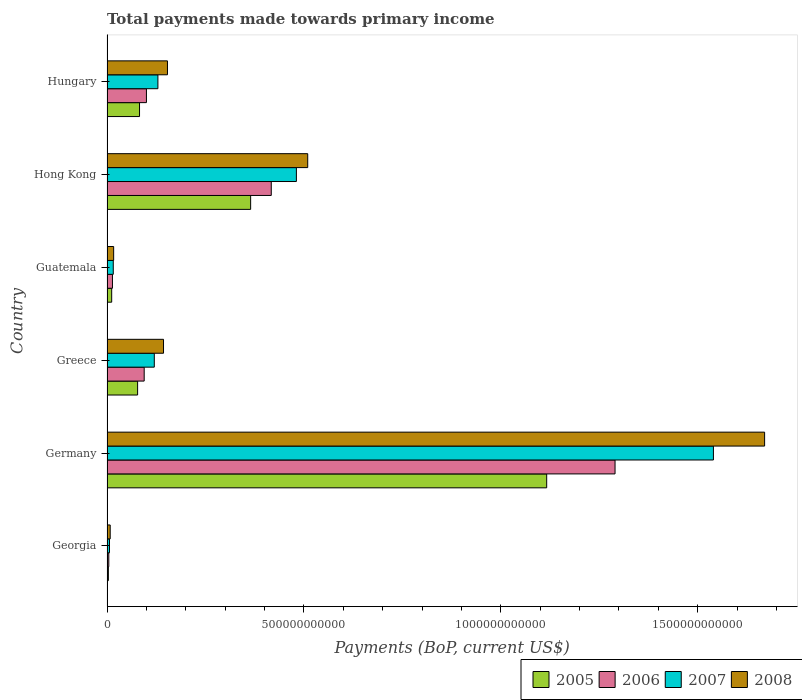How many different coloured bars are there?
Offer a terse response. 4. How many groups of bars are there?
Give a very brief answer. 6. Are the number of bars on each tick of the Y-axis equal?
Give a very brief answer. Yes. What is the label of the 3rd group of bars from the top?
Your answer should be compact. Guatemala. In how many cases, is the number of bars for a given country not equal to the number of legend labels?
Provide a short and direct response. 0. What is the total payments made towards primary income in 2008 in Hong Kong?
Ensure brevity in your answer.  5.10e+11. Across all countries, what is the maximum total payments made towards primary income in 2006?
Give a very brief answer. 1.29e+12. Across all countries, what is the minimum total payments made towards primary income in 2006?
Make the answer very short. 4.56e+09. In which country was the total payments made towards primary income in 2007 maximum?
Ensure brevity in your answer.  Germany. In which country was the total payments made towards primary income in 2007 minimum?
Your answer should be very brief. Georgia. What is the total total payments made towards primary income in 2006 in the graph?
Make the answer very short. 1.92e+12. What is the difference between the total payments made towards primary income in 2007 in Germany and that in Guatemala?
Keep it short and to the point. 1.52e+12. What is the difference between the total payments made towards primary income in 2007 in Guatemala and the total payments made towards primary income in 2005 in Germany?
Offer a very short reply. -1.10e+12. What is the average total payments made towards primary income in 2005 per country?
Ensure brevity in your answer.  2.76e+11. What is the difference between the total payments made towards primary income in 2006 and total payments made towards primary income in 2008 in Hong Kong?
Provide a succinct answer. -9.26e+1. In how many countries, is the total payments made towards primary income in 2007 greater than 1600000000000 US$?
Give a very brief answer. 0. What is the ratio of the total payments made towards primary income in 2005 in Germany to that in Hong Kong?
Ensure brevity in your answer.  3.06. Is the total payments made towards primary income in 2006 in Guatemala less than that in Hong Kong?
Provide a succinct answer. Yes. Is the difference between the total payments made towards primary income in 2006 in Germany and Hong Kong greater than the difference between the total payments made towards primary income in 2008 in Germany and Hong Kong?
Give a very brief answer. No. What is the difference between the highest and the second highest total payments made towards primary income in 2007?
Provide a short and direct response. 1.06e+12. What is the difference between the highest and the lowest total payments made towards primary income in 2008?
Provide a short and direct response. 1.66e+12. What does the 1st bar from the bottom in Hong Kong represents?
Keep it short and to the point. 2005. Are all the bars in the graph horizontal?
Ensure brevity in your answer.  Yes. How many countries are there in the graph?
Ensure brevity in your answer.  6. What is the difference between two consecutive major ticks on the X-axis?
Offer a very short reply. 5.00e+11. Does the graph contain grids?
Provide a short and direct response. No. Where does the legend appear in the graph?
Provide a succinct answer. Bottom right. What is the title of the graph?
Offer a terse response. Total payments made towards primary income. Does "2005" appear as one of the legend labels in the graph?
Give a very brief answer. Yes. What is the label or title of the X-axis?
Offer a terse response. Payments (BoP, current US$). What is the label or title of the Y-axis?
Ensure brevity in your answer.  Country. What is the Payments (BoP, current US$) of 2005 in Georgia?
Your answer should be very brief. 3.47e+09. What is the Payments (BoP, current US$) of 2006 in Georgia?
Provide a short and direct response. 4.56e+09. What is the Payments (BoP, current US$) of 2007 in Georgia?
Give a very brief answer. 6.32e+09. What is the Payments (BoP, current US$) in 2008 in Georgia?
Make the answer very short. 8.11e+09. What is the Payments (BoP, current US$) of 2005 in Germany?
Give a very brief answer. 1.12e+12. What is the Payments (BoP, current US$) of 2006 in Germany?
Offer a very short reply. 1.29e+12. What is the Payments (BoP, current US$) in 2007 in Germany?
Your answer should be very brief. 1.54e+12. What is the Payments (BoP, current US$) of 2008 in Germany?
Your answer should be compact. 1.67e+12. What is the Payments (BoP, current US$) in 2005 in Greece?
Offer a very short reply. 7.77e+1. What is the Payments (BoP, current US$) of 2006 in Greece?
Make the answer very short. 9.44e+1. What is the Payments (BoP, current US$) in 2007 in Greece?
Your response must be concise. 1.20e+11. What is the Payments (BoP, current US$) of 2008 in Greece?
Give a very brief answer. 1.44e+11. What is the Payments (BoP, current US$) of 2005 in Guatemala?
Ensure brevity in your answer.  1.19e+1. What is the Payments (BoP, current US$) of 2006 in Guatemala?
Give a very brief answer. 1.38e+1. What is the Payments (BoP, current US$) of 2007 in Guatemala?
Offer a very short reply. 1.59e+1. What is the Payments (BoP, current US$) in 2008 in Guatemala?
Offer a very short reply. 1.69e+1. What is the Payments (BoP, current US$) in 2005 in Hong Kong?
Your answer should be very brief. 3.65e+11. What is the Payments (BoP, current US$) of 2006 in Hong Kong?
Offer a terse response. 4.17e+11. What is the Payments (BoP, current US$) in 2007 in Hong Kong?
Your answer should be compact. 4.81e+11. What is the Payments (BoP, current US$) in 2008 in Hong Kong?
Ensure brevity in your answer.  5.10e+11. What is the Payments (BoP, current US$) of 2005 in Hungary?
Your answer should be compact. 8.26e+1. What is the Payments (BoP, current US$) of 2006 in Hungary?
Provide a short and direct response. 1.00e+11. What is the Payments (BoP, current US$) in 2007 in Hungary?
Keep it short and to the point. 1.29e+11. What is the Payments (BoP, current US$) of 2008 in Hungary?
Keep it short and to the point. 1.54e+11. Across all countries, what is the maximum Payments (BoP, current US$) of 2005?
Your answer should be very brief. 1.12e+12. Across all countries, what is the maximum Payments (BoP, current US$) in 2006?
Your answer should be compact. 1.29e+12. Across all countries, what is the maximum Payments (BoP, current US$) in 2007?
Offer a very short reply. 1.54e+12. Across all countries, what is the maximum Payments (BoP, current US$) of 2008?
Your response must be concise. 1.67e+12. Across all countries, what is the minimum Payments (BoP, current US$) in 2005?
Your answer should be compact. 3.47e+09. Across all countries, what is the minimum Payments (BoP, current US$) in 2006?
Provide a succinct answer. 4.56e+09. Across all countries, what is the minimum Payments (BoP, current US$) of 2007?
Provide a short and direct response. 6.32e+09. Across all countries, what is the minimum Payments (BoP, current US$) of 2008?
Provide a short and direct response. 8.11e+09. What is the total Payments (BoP, current US$) of 2005 in the graph?
Ensure brevity in your answer.  1.66e+12. What is the total Payments (BoP, current US$) in 2006 in the graph?
Give a very brief answer. 1.92e+12. What is the total Payments (BoP, current US$) of 2007 in the graph?
Offer a very short reply. 2.29e+12. What is the total Payments (BoP, current US$) in 2008 in the graph?
Ensure brevity in your answer.  2.50e+12. What is the difference between the Payments (BoP, current US$) of 2005 in Georgia and that in Germany?
Provide a succinct answer. -1.11e+12. What is the difference between the Payments (BoP, current US$) of 2006 in Georgia and that in Germany?
Offer a very short reply. -1.29e+12. What is the difference between the Payments (BoP, current US$) of 2007 in Georgia and that in Germany?
Ensure brevity in your answer.  -1.53e+12. What is the difference between the Payments (BoP, current US$) of 2008 in Georgia and that in Germany?
Ensure brevity in your answer.  -1.66e+12. What is the difference between the Payments (BoP, current US$) in 2005 in Georgia and that in Greece?
Offer a very short reply. -7.43e+1. What is the difference between the Payments (BoP, current US$) of 2006 in Georgia and that in Greece?
Offer a very short reply. -8.99e+1. What is the difference between the Payments (BoP, current US$) in 2007 in Georgia and that in Greece?
Your answer should be very brief. -1.14e+11. What is the difference between the Payments (BoP, current US$) of 2008 in Georgia and that in Greece?
Your response must be concise. -1.35e+11. What is the difference between the Payments (BoP, current US$) in 2005 in Georgia and that in Guatemala?
Provide a succinct answer. -8.42e+09. What is the difference between the Payments (BoP, current US$) of 2006 in Georgia and that in Guatemala?
Ensure brevity in your answer.  -9.27e+09. What is the difference between the Payments (BoP, current US$) of 2007 in Georgia and that in Guatemala?
Your answer should be compact. -9.59e+09. What is the difference between the Payments (BoP, current US$) of 2008 in Georgia and that in Guatemala?
Your answer should be compact. -8.77e+09. What is the difference between the Payments (BoP, current US$) of 2005 in Georgia and that in Hong Kong?
Keep it short and to the point. -3.61e+11. What is the difference between the Payments (BoP, current US$) in 2006 in Georgia and that in Hong Kong?
Keep it short and to the point. -4.13e+11. What is the difference between the Payments (BoP, current US$) of 2007 in Georgia and that in Hong Kong?
Provide a succinct answer. -4.75e+11. What is the difference between the Payments (BoP, current US$) in 2008 in Georgia and that in Hong Kong?
Keep it short and to the point. -5.02e+11. What is the difference between the Payments (BoP, current US$) in 2005 in Georgia and that in Hungary?
Your response must be concise. -7.91e+1. What is the difference between the Payments (BoP, current US$) of 2006 in Georgia and that in Hungary?
Your answer should be compact. -9.56e+1. What is the difference between the Payments (BoP, current US$) of 2007 in Georgia and that in Hungary?
Offer a terse response. -1.23e+11. What is the difference between the Payments (BoP, current US$) of 2008 in Georgia and that in Hungary?
Give a very brief answer. -1.45e+11. What is the difference between the Payments (BoP, current US$) of 2005 in Germany and that in Greece?
Keep it short and to the point. 1.04e+12. What is the difference between the Payments (BoP, current US$) of 2006 in Germany and that in Greece?
Provide a short and direct response. 1.20e+12. What is the difference between the Payments (BoP, current US$) of 2007 in Germany and that in Greece?
Keep it short and to the point. 1.42e+12. What is the difference between the Payments (BoP, current US$) of 2008 in Germany and that in Greece?
Ensure brevity in your answer.  1.53e+12. What is the difference between the Payments (BoP, current US$) of 2005 in Germany and that in Guatemala?
Provide a succinct answer. 1.10e+12. What is the difference between the Payments (BoP, current US$) in 2006 in Germany and that in Guatemala?
Offer a terse response. 1.28e+12. What is the difference between the Payments (BoP, current US$) in 2007 in Germany and that in Guatemala?
Your answer should be very brief. 1.52e+12. What is the difference between the Payments (BoP, current US$) of 2008 in Germany and that in Guatemala?
Your answer should be compact. 1.65e+12. What is the difference between the Payments (BoP, current US$) of 2005 in Germany and that in Hong Kong?
Keep it short and to the point. 7.52e+11. What is the difference between the Payments (BoP, current US$) of 2006 in Germany and that in Hong Kong?
Ensure brevity in your answer.  8.73e+11. What is the difference between the Payments (BoP, current US$) of 2007 in Germany and that in Hong Kong?
Your answer should be compact. 1.06e+12. What is the difference between the Payments (BoP, current US$) of 2008 in Germany and that in Hong Kong?
Give a very brief answer. 1.16e+12. What is the difference between the Payments (BoP, current US$) in 2005 in Germany and that in Hungary?
Provide a short and direct response. 1.03e+12. What is the difference between the Payments (BoP, current US$) of 2006 in Germany and that in Hungary?
Keep it short and to the point. 1.19e+12. What is the difference between the Payments (BoP, current US$) of 2007 in Germany and that in Hungary?
Keep it short and to the point. 1.41e+12. What is the difference between the Payments (BoP, current US$) in 2008 in Germany and that in Hungary?
Ensure brevity in your answer.  1.52e+12. What is the difference between the Payments (BoP, current US$) in 2005 in Greece and that in Guatemala?
Your answer should be very brief. 6.58e+1. What is the difference between the Payments (BoP, current US$) in 2006 in Greece and that in Guatemala?
Your response must be concise. 8.06e+1. What is the difference between the Payments (BoP, current US$) of 2007 in Greece and that in Guatemala?
Offer a very short reply. 1.04e+11. What is the difference between the Payments (BoP, current US$) of 2008 in Greece and that in Guatemala?
Your answer should be compact. 1.27e+11. What is the difference between the Payments (BoP, current US$) of 2005 in Greece and that in Hong Kong?
Make the answer very short. -2.87e+11. What is the difference between the Payments (BoP, current US$) in 2006 in Greece and that in Hong Kong?
Offer a terse response. -3.23e+11. What is the difference between the Payments (BoP, current US$) in 2007 in Greece and that in Hong Kong?
Make the answer very short. -3.61e+11. What is the difference between the Payments (BoP, current US$) of 2008 in Greece and that in Hong Kong?
Ensure brevity in your answer.  -3.66e+11. What is the difference between the Payments (BoP, current US$) in 2005 in Greece and that in Hungary?
Offer a terse response. -4.89e+09. What is the difference between the Payments (BoP, current US$) in 2006 in Greece and that in Hungary?
Keep it short and to the point. -5.71e+09. What is the difference between the Payments (BoP, current US$) of 2007 in Greece and that in Hungary?
Keep it short and to the point. -9.18e+09. What is the difference between the Payments (BoP, current US$) of 2008 in Greece and that in Hungary?
Offer a very short reply. -1.00e+1. What is the difference between the Payments (BoP, current US$) of 2005 in Guatemala and that in Hong Kong?
Your answer should be compact. -3.53e+11. What is the difference between the Payments (BoP, current US$) of 2006 in Guatemala and that in Hong Kong?
Provide a succinct answer. -4.03e+11. What is the difference between the Payments (BoP, current US$) of 2007 in Guatemala and that in Hong Kong?
Make the answer very short. -4.65e+11. What is the difference between the Payments (BoP, current US$) of 2008 in Guatemala and that in Hong Kong?
Your answer should be very brief. -4.93e+11. What is the difference between the Payments (BoP, current US$) in 2005 in Guatemala and that in Hungary?
Provide a succinct answer. -7.07e+1. What is the difference between the Payments (BoP, current US$) of 2006 in Guatemala and that in Hungary?
Your answer should be very brief. -8.63e+1. What is the difference between the Payments (BoP, current US$) of 2007 in Guatemala and that in Hungary?
Ensure brevity in your answer.  -1.13e+11. What is the difference between the Payments (BoP, current US$) of 2008 in Guatemala and that in Hungary?
Offer a terse response. -1.37e+11. What is the difference between the Payments (BoP, current US$) in 2005 in Hong Kong and that in Hungary?
Offer a terse response. 2.82e+11. What is the difference between the Payments (BoP, current US$) in 2006 in Hong Kong and that in Hungary?
Your response must be concise. 3.17e+11. What is the difference between the Payments (BoP, current US$) in 2007 in Hong Kong and that in Hungary?
Provide a succinct answer. 3.52e+11. What is the difference between the Payments (BoP, current US$) in 2008 in Hong Kong and that in Hungary?
Your answer should be very brief. 3.56e+11. What is the difference between the Payments (BoP, current US$) in 2005 in Georgia and the Payments (BoP, current US$) in 2006 in Germany?
Offer a very short reply. -1.29e+12. What is the difference between the Payments (BoP, current US$) in 2005 in Georgia and the Payments (BoP, current US$) in 2007 in Germany?
Offer a very short reply. -1.54e+12. What is the difference between the Payments (BoP, current US$) of 2005 in Georgia and the Payments (BoP, current US$) of 2008 in Germany?
Your answer should be very brief. -1.67e+12. What is the difference between the Payments (BoP, current US$) of 2006 in Georgia and the Payments (BoP, current US$) of 2007 in Germany?
Offer a very short reply. -1.54e+12. What is the difference between the Payments (BoP, current US$) in 2006 in Georgia and the Payments (BoP, current US$) in 2008 in Germany?
Offer a terse response. -1.67e+12. What is the difference between the Payments (BoP, current US$) of 2007 in Georgia and the Payments (BoP, current US$) of 2008 in Germany?
Provide a succinct answer. -1.66e+12. What is the difference between the Payments (BoP, current US$) of 2005 in Georgia and the Payments (BoP, current US$) of 2006 in Greece?
Keep it short and to the point. -9.10e+1. What is the difference between the Payments (BoP, current US$) in 2005 in Georgia and the Payments (BoP, current US$) in 2007 in Greece?
Provide a succinct answer. -1.17e+11. What is the difference between the Payments (BoP, current US$) of 2005 in Georgia and the Payments (BoP, current US$) of 2008 in Greece?
Offer a very short reply. -1.40e+11. What is the difference between the Payments (BoP, current US$) in 2006 in Georgia and the Payments (BoP, current US$) in 2007 in Greece?
Your answer should be very brief. -1.16e+11. What is the difference between the Payments (BoP, current US$) of 2006 in Georgia and the Payments (BoP, current US$) of 2008 in Greece?
Give a very brief answer. -1.39e+11. What is the difference between the Payments (BoP, current US$) of 2007 in Georgia and the Payments (BoP, current US$) of 2008 in Greece?
Provide a short and direct response. -1.37e+11. What is the difference between the Payments (BoP, current US$) in 2005 in Georgia and the Payments (BoP, current US$) in 2006 in Guatemala?
Ensure brevity in your answer.  -1.04e+1. What is the difference between the Payments (BoP, current US$) of 2005 in Georgia and the Payments (BoP, current US$) of 2007 in Guatemala?
Ensure brevity in your answer.  -1.24e+1. What is the difference between the Payments (BoP, current US$) in 2005 in Georgia and the Payments (BoP, current US$) in 2008 in Guatemala?
Your answer should be very brief. -1.34e+1. What is the difference between the Payments (BoP, current US$) in 2006 in Georgia and the Payments (BoP, current US$) in 2007 in Guatemala?
Give a very brief answer. -1.14e+1. What is the difference between the Payments (BoP, current US$) in 2006 in Georgia and the Payments (BoP, current US$) in 2008 in Guatemala?
Offer a terse response. -1.23e+1. What is the difference between the Payments (BoP, current US$) in 2007 in Georgia and the Payments (BoP, current US$) in 2008 in Guatemala?
Offer a very short reply. -1.06e+1. What is the difference between the Payments (BoP, current US$) in 2005 in Georgia and the Payments (BoP, current US$) in 2006 in Hong Kong?
Your answer should be very brief. -4.14e+11. What is the difference between the Payments (BoP, current US$) in 2005 in Georgia and the Payments (BoP, current US$) in 2007 in Hong Kong?
Offer a very short reply. -4.77e+11. What is the difference between the Payments (BoP, current US$) in 2005 in Georgia and the Payments (BoP, current US$) in 2008 in Hong Kong?
Provide a succinct answer. -5.06e+11. What is the difference between the Payments (BoP, current US$) of 2006 in Georgia and the Payments (BoP, current US$) of 2007 in Hong Kong?
Your answer should be very brief. -4.76e+11. What is the difference between the Payments (BoP, current US$) of 2006 in Georgia and the Payments (BoP, current US$) of 2008 in Hong Kong?
Your answer should be very brief. -5.05e+11. What is the difference between the Payments (BoP, current US$) in 2007 in Georgia and the Payments (BoP, current US$) in 2008 in Hong Kong?
Make the answer very short. -5.03e+11. What is the difference between the Payments (BoP, current US$) of 2005 in Georgia and the Payments (BoP, current US$) of 2006 in Hungary?
Keep it short and to the point. -9.67e+1. What is the difference between the Payments (BoP, current US$) in 2005 in Georgia and the Payments (BoP, current US$) in 2007 in Hungary?
Your answer should be compact. -1.26e+11. What is the difference between the Payments (BoP, current US$) in 2005 in Georgia and the Payments (BoP, current US$) in 2008 in Hungary?
Provide a short and direct response. -1.50e+11. What is the difference between the Payments (BoP, current US$) of 2006 in Georgia and the Payments (BoP, current US$) of 2007 in Hungary?
Your answer should be compact. -1.25e+11. What is the difference between the Payments (BoP, current US$) of 2006 in Georgia and the Payments (BoP, current US$) of 2008 in Hungary?
Your answer should be very brief. -1.49e+11. What is the difference between the Payments (BoP, current US$) in 2007 in Georgia and the Payments (BoP, current US$) in 2008 in Hungary?
Ensure brevity in your answer.  -1.47e+11. What is the difference between the Payments (BoP, current US$) in 2005 in Germany and the Payments (BoP, current US$) in 2006 in Greece?
Keep it short and to the point. 1.02e+12. What is the difference between the Payments (BoP, current US$) in 2005 in Germany and the Payments (BoP, current US$) in 2007 in Greece?
Your answer should be compact. 9.96e+11. What is the difference between the Payments (BoP, current US$) in 2005 in Germany and the Payments (BoP, current US$) in 2008 in Greece?
Provide a succinct answer. 9.73e+11. What is the difference between the Payments (BoP, current US$) in 2006 in Germany and the Payments (BoP, current US$) in 2007 in Greece?
Offer a terse response. 1.17e+12. What is the difference between the Payments (BoP, current US$) of 2006 in Germany and the Payments (BoP, current US$) of 2008 in Greece?
Offer a terse response. 1.15e+12. What is the difference between the Payments (BoP, current US$) of 2007 in Germany and the Payments (BoP, current US$) of 2008 in Greece?
Ensure brevity in your answer.  1.40e+12. What is the difference between the Payments (BoP, current US$) in 2005 in Germany and the Payments (BoP, current US$) in 2006 in Guatemala?
Make the answer very short. 1.10e+12. What is the difference between the Payments (BoP, current US$) in 2005 in Germany and the Payments (BoP, current US$) in 2007 in Guatemala?
Your answer should be compact. 1.10e+12. What is the difference between the Payments (BoP, current US$) in 2005 in Germany and the Payments (BoP, current US$) in 2008 in Guatemala?
Your answer should be compact. 1.10e+12. What is the difference between the Payments (BoP, current US$) in 2006 in Germany and the Payments (BoP, current US$) in 2007 in Guatemala?
Your answer should be very brief. 1.27e+12. What is the difference between the Payments (BoP, current US$) of 2006 in Germany and the Payments (BoP, current US$) of 2008 in Guatemala?
Keep it short and to the point. 1.27e+12. What is the difference between the Payments (BoP, current US$) in 2007 in Germany and the Payments (BoP, current US$) in 2008 in Guatemala?
Offer a very short reply. 1.52e+12. What is the difference between the Payments (BoP, current US$) of 2005 in Germany and the Payments (BoP, current US$) of 2006 in Hong Kong?
Keep it short and to the point. 6.99e+11. What is the difference between the Payments (BoP, current US$) in 2005 in Germany and the Payments (BoP, current US$) in 2007 in Hong Kong?
Your answer should be very brief. 6.36e+11. What is the difference between the Payments (BoP, current US$) in 2005 in Germany and the Payments (BoP, current US$) in 2008 in Hong Kong?
Give a very brief answer. 6.07e+11. What is the difference between the Payments (BoP, current US$) of 2006 in Germany and the Payments (BoP, current US$) of 2007 in Hong Kong?
Provide a succinct answer. 8.09e+11. What is the difference between the Payments (BoP, current US$) in 2006 in Germany and the Payments (BoP, current US$) in 2008 in Hong Kong?
Provide a short and direct response. 7.80e+11. What is the difference between the Payments (BoP, current US$) in 2007 in Germany and the Payments (BoP, current US$) in 2008 in Hong Kong?
Your answer should be compact. 1.03e+12. What is the difference between the Payments (BoP, current US$) in 2005 in Germany and the Payments (BoP, current US$) in 2006 in Hungary?
Your answer should be very brief. 1.02e+12. What is the difference between the Payments (BoP, current US$) in 2005 in Germany and the Payments (BoP, current US$) in 2007 in Hungary?
Keep it short and to the point. 9.87e+11. What is the difference between the Payments (BoP, current US$) in 2005 in Germany and the Payments (BoP, current US$) in 2008 in Hungary?
Give a very brief answer. 9.63e+11. What is the difference between the Payments (BoP, current US$) in 2006 in Germany and the Payments (BoP, current US$) in 2007 in Hungary?
Offer a terse response. 1.16e+12. What is the difference between the Payments (BoP, current US$) in 2006 in Germany and the Payments (BoP, current US$) in 2008 in Hungary?
Provide a short and direct response. 1.14e+12. What is the difference between the Payments (BoP, current US$) of 2007 in Germany and the Payments (BoP, current US$) of 2008 in Hungary?
Make the answer very short. 1.39e+12. What is the difference between the Payments (BoP, current US$) of 2005 in Greece and the Payments (BoP, current US$) of 2006 in Guatemala?
Make the answer very short. 6.39e+1. What is the difference between the Payments (BoP, current US$) in 2005 in Greece and the Payments (BoP, current US$) in 2007 in Guatemala?
Provide a short and direct response. 6.18e+1. What is the difference between the Payments (BoP, current US$) of 2005 in Greece and the Payments (BoP, current US$) of 2008 in Guatemala?
Offer a terse response. 6.08e+1. What is the difference between the Payments (BoP, current US$) of 2006 in Greece and the Payments (BoP, current US$) of 2007 in Guatemala?
Keep it short and to the point. 7.85e+1. What is the difference between the Payments (BoP, current US$) of 2006 in Greece and the Payments (BoP, current US$) of 2008 in Guatemala?
Give a very brief answer. 7.76e+1. What is the difference between the Payments (BoP, current US$) of 2007 in Greece and the Payments (BoP, current US$) of 2008 in Guatemala?
Make the answer very short. 1.03e+11. What is the difference between the Payments (BoP, current US$) of 2005 in Greece and the Payments (BoP, current US$) of 2006 in Hong Kong?
Your response must be concise. -3.39e+11. What is the difference between the Payments (BoP, current US$) of 2005 in Greece and the Payments (BoP, current US$) of 2007 in Hong Kong?
Make the answer very short. -4.03e+11. What is the difference between the Payments (BoP, current US$) in 2005 in Greece and the Payments (BoP, current US$) in 2008 in Hong Kong?
Make the answer very short. -4.32e+11. What is the difference between the Payments (BoP, current US$) of 2006 in Greece and the Payments (BoP, current US$) of 2007 in Hong Kong?
Provide a short and direct response. -3.86e+11. What is the difference between the Payments (BoP, current US$) in 2006 in Greece and the Payments (BoP, current US$) in 2008 in Hong Kong?
Your answer should be compact. -4.15e+11. What is the difference between the Payments (BoP, current US$) of 2007 in Greece and the Payments (BoP, current US$) of 2008 in Hong Kong?
Provide a short and direct response. -3.90e+11. What is the difference between the Payments (BoP, current US$) of 2005 in Greece and the Payments (BoP, current US$) of 2006 in Hungary?
Your response must be concise. -2.24e+1. What is the difference between the Payments (BoP, current US$) in 2005 in Greece and the Payments (BoP, current US$) in 2007 in Hungary?
Provide a short and direct response. -5.16e+1. What is the difference between the Payments (BoP, current US$) of 2005 in Greece and the Payments (BoP, current US$) of 2008 in Hungary?
Give a very brief answer. -7.58e+1. What is the difference between the Payments (BoP, current US$) in 2006 in Greece and the Payments (BoP, current US$) in 2007 in Hungary?
Keep it short and to the point. -3.48e+1. What is the difference between the Payments (BoP, current US$) in 2006 in Greece and the Payments (BoP, current US$) in 2008 in Hungary?
Give a very brief answer. -5.91e+1. What is the difference between the Payments (BoP, current US$) in 2007 in Greece and the Payments (BoP, current US$) in 2008 in Hungary?
Your answer should be very brief. -3.34e+1. What is the difference between the Payments (BoP, current US$) in 2005 in Guatemala and the Payments (BoP, current US$) in 2006 in Hong Kong?
Ensure brevity in your answer.  -4.05e+11. What is the difference between the Payments (BoP, current US$) of 2005 in Guatemala and the Payments (BoP, current US$) of 2007 in Hong Kong?
Offer a terse response. -4.69e+11. What is the difference between the Payments (BoP, current US$) of 2005 in Guatemala and the Payments (BoP, current US$) of 2008 in Hong Kong?
Your answer should be compact. -4.98e+11. What is the difference between the Payments (BoP, current US$) in 2006 in Guatemala and the Payments (BoP, current US$) in 2007 in Hong Kong?
Ensure brevity in your answer.  -4.67e+11. What is the difference between the Payments (BoP, current US$) in 2006 in Guatemala and the Payments (BoP, current US$) in 2008 in Hong Kong?
Give a very brief answer. -4.96e+11. What is the difference between the Payments (BoP, current US$) in 2007 in Guatemala and the Payments (BoP, current US$) in 2008 in Hong Kong?
Your answer should be very brief. -4.94e+11. What is the difference between the Payments (BoP, current US$) in 2005 in Guatemala and the Payments (BoP, current US$) in 2006 in Hungary?
Your response must be concise. -8.83e+1. What is the difference between the Payments (BoP, current US$) in 2005 in Guatemala and the Payments (BoP, current US$) in 2007 in Hungary?
Make the answer very short. -1.17e+11. What is the difference between the Payments (BoP, current US$) in 2005 in Guatemala and the Payments (BoP, current US$) in 2008 in Hungary?
Provide a short and direct response. -1.42e+11. What is the difference between the Payments (BoP, current US$) in 2006 in Guatemala and the Payments (BoP, current US$) in 2007 in Hungary?
Provide a succinct answer. -1.15e+11. What is the difference between the Payments (BoP, current US$) in 2006 in Guatemala and the Payments (BoP, current US$) in 2008 in Hungary?
Provide a succinct answer. -1.40e+11. What is the difference between the Payments (BoP, current US$) in 2007 in Guatemala and the Payments (BoP, current US$) in 2008 in Hungary?
Your answer should be very brief. -1.38e+11. What is the difference between the Payments (BoP, current US$) of 2005 in Hong Kong and the Payments (BoP, current US$) of 2006 in Hungary?
Keep it short and to the point. 2.65e+11. What is the difference between the Payments (BoP, current US$) in 2005 in Hong Kong and the Payments (BoP, current US$) in 2007 in Hungary?
Your answer should be very brief. 2.35e+11. What is the difference between the Payments (BoP, current US$) in 2005 in Hong Kong and the Payments (BoP, current US$) in 2008 in Hungary?
Your answer should be compact. 2.11e+11. What is the difference between the Payments (BoP, current US$) in 2006 in Hong Kong and the Payments (BoP, current US$) in 2007 in Hungary?
Your answer should be compact. 2.88e+11. What is the difference between the Payments (BoP, current US$) in 2006 in Hong Kong and the Payments (BoP, current US$) in 2008 in Hungary?
Your answer should be compact. 2.64e+11. What is the difference between the Payments (BoP, current US$) of 2007 in Hong Kong and the Payments (BoP, current US$) of 2008 in Hungary?
Offer a very short reply. 3.27e+11. What is the average Payments (BoP, current US$) of 2005 per country?
Keep it short and to the point. 2.76e+11. What is the average Payments (BoP, current US$) in 2006 per country?
Give a very brief answer. 3.20e+11. What is the average Payments (BoP, current US$) in 2007 per country?
Your answer should be compact. 3.82e+11. What is the average Payments (BoP, current US$) in 2008 per country?
Give a very brief answer. 4.17e+11. What is the difference between the Payments (BoP, current US$) of 2005 and Payments (BoP, current US$) of 2006 in Georgia?
Give a very brief answer. -1.09e+09. What is the difference between the Payments (BoP, current US$) in 2005 and Payments (BoP, current US$) in 2007 in Georgia?
Provide a succinct answer. -2.86e+09. What is the difference between the Payments (BoP, current US$) in 2005 and Payments (BoP, current US$) in 2008 in Georgia?
Offer a terse response. -4.65e+09. What is the difference between the Payments (BoP, current US$) in 2006 and Payments (BoP, current US$) in 2007 in Georgia?
Keep it short and to the point. -1.77e+09. What is the difference between the Payments (BoP, current US$) of 2006 and Payments (BoP, current US$) of 2008 in Georgia?
Keep it short and to the point. -3.56e+09. What is the difference between the Payments (BoP, current US$) in 2007 and Payments (BoP, current US$) in 2008 in Georgia?
Offer a terse response. -1.79e+09. What is the difference between the Payments (BoP, current US$) in 2005 and Payments (BoP, current US$) in 2006 in Germany?
Offer a very short reply. -1.74e+11. What is the difference between the Payments (BoP, current US$) in 2005 and Payments (BoP, current US$) in 2007 in Germany?
Offer a very short reply. -4.23e+11. What is the difference between the Payments (BoP, current US$) of 2005 and Payments (BoP, current US$) of 2008 in Germany?
Offer a very short reply. -5.53e+11. What is the difference between the Payments (BoP, current US$) of 2006 and Payments (BoP, current US$) of 2007 in Germany?
Your response must be concise. -2.50e+11. What is the difference between the Payments (BoP, current US$) of 2006 and Payments (BoP, current US$) of 2008 in Germany?
Your answer should be very brief. -3.80e+11. What is the difference between the Payments (BoP, current US$) of 2007 and Payments (BoP, current US$) of 2008 in Germany?
Keep it short and to the point. -1.30e+11. What is the difference between the Payments (BoP, current US$) in 2005 and Payments (BoP, current US$) in 2006 in Greece?
Offer a very short reply. -1.67e+1. What is the difference between the Payments (BoP, current US$) in 2005 and Payments (BoP, current US$) in 2007 in Greece?
Your answer should be compact. -4.24e+1. What is the difference between the Payments (BoP, current US$) of 2005 and Payments (BoP, current US$) of 2008 in Greece?
Your response must be concise. -6.58e+1. What is the difference between the Payments (BoP, current US$) in 2006 and Payments (BoP, current US$) in 2007 in Greece?
Make the answer very short. -2.56e+1. What is the difference between the Payments (BoP, current US$) in 2006 and Payments (BoP, current US$) in 2008 in Greece?
Your answer should be compact. -4.91e+1. What is the difference between the Payments (BoP, current US$) of 2007 and Payments (BoP, current US$) of 2008 in Greece?
Ensure brevity in your answer.  -2.34e+1. What is the difference between the Payments (BoP, current US$) of 2005 and Payments (BoP, current US$) of 2006 in Guatemala?
Provide a short and direct response. -1.94e+09. What is the difference between the Payments (BoP, current US$) in 2005 and Payments (BoP, current US$) in 2007 in Guatemala?
Make the answer very short. -4.02e+09. What is the difference between the Payments (BoP, current US$) of 2005 and Payments (BoP, current US$) of 2008 in Guatemala?
Give a very brief answer. -5.00e+09. What is the difference between the Payments (BoP, current US$) in 2006 and Payments (BoP, current US$) in 2007 in Guatemala?
Your answer should be very brief. -2.08e+09. What is the difference between the Payments (BoP, current US$) of 2006 and Payments (BoP, current US$) of 2008 in Guatemala?
Give a very brief answer. -3.06e+09. What is the difference between the Payments (BoP, current US$) in 2007 and Payments (BoP, current US$) in 2008 in Guatemala?
Your answer should be very brief. -9.78e+08. What is the difference between the Payments (BoP, current US$) of 2005 and Payments (BoP, current US$) of 2006 in Hong Kong?
Your response must be concise. -5.24e+1. What is the difference between the Payments (BoP, current US$) in 2005 and Payments (BoP, current US$) in 2007 in Hong Kong?
Provide a succinct answer. -1.16e+11. What is the difference between the Payments (BoP, current US$) of 2005 and Payments (BoP, current US$) of 2008 in Hong Kong?
Provide a short and direct response. -1.45e+11. What is the difference between the Payments (BoP, current US$) in 2006 and Payments (BoP, current US$) in 2007 in Hong Kong?
Keep it short and to the point. -6.38e+1. What is the difference between the Payments (BoP, current US$) in 2006 and Payments (BoP, current US$) in 2008 in Hong Kong?
Your answer should be very brief. -9.26e+1. What is the difference between the Payments (BoP, current US$) in 2007 and Payments (BoP, current US$) in 2008 in Hong Kong?
Make the answer very short. -2.88e+1. What is the difference between the Payments (BoP, current US$) of 2005 and Payments (BoP, current US$) of 2006 in Hungary?
Make the answer very short. -1.75e+1. What is the difference between the Payments (BoP, current US$) of 2005 and Payments (BoP, current US$) of 2007 in Hungary?
Offer a terse response. -4.67e+1. What is the difference between the Payments (BoP, current US$) of 2005 and Payments (BoP, current US$) of 2008 in Hungary?
Ensure brevity in your answer.  -7.09e+1. What is the difference between the Payments (BoP, current US$) of 2006 and Payments (BoP, current US$) of 2007 in Hungary?
Keep it short and to the point. -2.91e+1. What is the difference between the Payments (BoP, current US$) in 2006 and Payments (BoP, current US$) in 2008 in Hungary?
Your response must be concise. -5.34e+1. What is the difference between the Payments (BoP, current US$) in 2007 and Payments (BoP, current US$) in 2008 in Hungary?
Give a very brief answer. -2.43e+1. What is the ratio of the Payments (BoP, current US$) in 2005 in Georgia to that in Germany?
Offer a terse response. 0. What is the ratio of the Payments (BoP, current US$) of 2006 in Georgia to that in Germany?
Provide a short and direct response. 0. What is the ratio of the Payments (BoP, current US$) of 2007 in Georgia to that in Germany?
Offer a terse response. 0. What is the ratio of the Payments (BoP, current US$) of 2008 in Georgia to that in Germany?
Your answer should be compact. 0. What is the ratio of the Payments (BoP, current US$) of 2005 in Georgia to that in Greece?
Offer a terse response. 0.04. What is the ratio of the Payments (BoP, current US$) of 2006 in Georgia to that in Greece?
Your response must be concise. 0.05. What is the ratio of the Payments (BoP, current US$) in 2007 in Georgia to that in Greece?
Keep it short and to the point. 0.05. What is the ratio of the Payments (BoP, current US$) of 2008 in Georgia to that in Greece?
Your answer should be compact. 0.06. What is the ratio of the Payments (BoP, current US$) in 2005 in Georgia to that in Guatemala?
Offer a terse response. 0.29. What is the ratio of the Payments (BoP, current US$) in 2006 in Georgia to that in Guatemala?
Provide a succinct answer. 0.33. What is the ratio of the Payments (BoP, current US$) in 2007 in Georgia to that in Guatemala?
Make the answer very short. 0.4. What is the ratio of the Payments (BoP, current US$) of 2008 in Georgia to that in Guatemala?
Make the answer very short. 0.48. What is the ratio of the Payments (BoP, current US$) in 2005 in Georgia to that in Hong Kong?
Ensure brevity in your answer.  0.01. What is the ratio of the Payments (BoP, current US$) of 2006 in Georgia to that in Hong Kong?
Provide a succinct answer. 0.01. What is the ratio of the Payments (BoP, current US$) in 2007 in Georgia to that in Hong Kong?
Ensure brevity in your answer.  0.01. What is the ratio of the Payments (BoP, current US$) in 2008 in Georgia to that in Hong Kong?
Provide a succinct answer. 0.02. What is the ratio of the Payments (BoP, current US$) in 2005 in Georgia to that in Hungary?
Your answer should be compact. 0.04. What is the ratio of the Payments (BoP, current US$) of 2006 in Georgia to that in Hungary?
Your response must be concise. 0.05. What is the ratio of the Payments (BoP, current US$) of 2007 in Georgia to that in Hungary?
Provide a short and direct response. 0.05. What is the ratio of the Payments (BoP, current US$) in 2008 in Georgia to that in Hungary?
Ensure brevity in your answer.  0.05. What is the ratio of the Payments (BoP, current US$) in 2005 in Germany to that in Greece?
Your answer should be very brief. 14.37. What is the ratio of the Payments (BoP, current US$) of 2006 in Germany to that in Greece?
Your response must be concise. 13.66. What is the ratio of the Payments (BoP, current US$) of 2007 in Germany to that in Greece?
Keep it short and to the point. 12.82. What is the ratio of the Payments (BoP, current US$) of 2008 in Germany to that in Greece?
Provide a short and direct response. 11.64. What is the ratio of the Payments (BoP, current US$) in 2005 in Germany to that in Guatemala?
Provide a short and direct response. 93.94. What is the ratio of the Payments (BoP, current US$) of 2006 in Germany to that in Guatemala?
Provide a succinct answer. 93.3. What is the ratio of the Payments (BoP, current US$) of 2007 in Germany to that in Guatemala?
Ensure brevity in your answer.  96.79. What is the ratio of the Payments (BoP, current US$) of 2008 in Germany to that in Guatemala?
Offer a very short reply. 98.88. What is the ratio of the Payments (BoP, current US$) of 2005 in Germany to that in Hong Kong?
Keep it short and to the point. 3.06. What is the ratio of the Payments (BoP, current US$) in 2006 in Germany to that in Hong Kong?
Give a very brief answer. 3.09. What is the ratio of the Payments (BoP, current US$) in 2007 in Germany to that in Hong Kong?
Ensure brevity in your answer.  3.2. What is the ratio of the Payments (BoP, current US$) in 2008 in Germany to that in Hong Kong?
Give a very brief answer. 3.28. What is the ratio of the Payments (BoP, current US$) in 2005 in Germany to that in Hungary?
Offer a terse response. 13.52. What is the ratio of the Payments (BoP, current US$) of 2006 in Germany to that in Hungary?
Ensure brevity in your answer.  12.88. What is the ratio of the Payments (BoP, current US$) of 2007 in Germany to that in Hungary?
Offer a very short reply. 11.91. What is the ratio of the Payments (BoP, current US$) in 2008 in Germany to that in Hungary?
Offer a terse response. 10.88. What is the ratio of the Payments (BoP, current US$) in 2005 in Greece to that in Guatemala?
Make the answer very short. 6.54. What is the ratio of the Payments (BoP, current US$) in 2006 in Greece to that in Guatemala?
Ensure brevity in your answer.  6.83. What is the ratio of the Payments (BoP, current US$) in 2007 in Greece to that in Guatemala?
Your response must be concise. 7.55. What is the ratio of the Payments (BoP, current US$) in 2008 in Greece to that in Guatemala?
Offer a very short reply. 8.5. What is the ratio of the Payments (BoP, current US$) in 2005 in Greece to that in Hong Kong?
Your answer should be compact. 0.21. What is the ratio of the Payments (BoP, current US$) of 2006 in Greece to that in Hong Kong?
Keep it short and to the point. 0.23. What is the ratio of the Payments (BoP, current US$) in 2007 in Greece to that in Hong Kong?
Ensure brevity in your answer.  0.25. What is the ratio of the Payments (BoP, current US$) of 2008 in Greece to that in Hong Kong?
Provide a succinct answer. 0.28. What is the ratio of the Payments (BoP, current US$) of 2005 in Greece to that in Hungary?
Offer a terse response. 0.94. What is the ratio of the Payments (BoP, current US$) of 2006 in Greece to that in Hungary?
Your answer should be compact. 0.94. What is the ratio of the Payments (BoP, current US$) in 2007 in Greece to that in Hungary?
Offer a terse response. 0.93. What is the ratio of the Payments (BoP, current US$) in 2008 in Greece to that in Hungary?
Provide a succinct answer. 0.93. What is the ratio of the Payments (BoP, current US$) in 2005 in Guatemala to that in Hong Kong?
Offer a terse response. 0.03. What is the ratio of the Payments (BoP, current US$) of 2006 in Guatemala to that in Hong Kong?
Offer a very short reply. 0.03. What is the ratio of the Payments (BoP, current US$) in 2007 in Guatemala to that in Hong Kong?
Provide a short and direct response. 0.03. What is the ratio of the Payments (BoP, current US$) of 2008 in Guatemala to that in Hong Kong?
Offer a terse response. 0.03. What is the ratio of the Payments (BoP, current US$) in 2005 in Guatemala to that in Hungary?
Your response must be concise. 0.14. What is the ratio of the Payments (BoP, current US$) of 2006 in Guatemala to that in Hungary?
Give a very brief answer. 0.14. What is the ratio of the Payments (BoP, current US$) in 2007 in Guatemala to that in Hungary?
Keep it short and to the point. 0.12. What is the ratio of the Payments (BoP, current US$) in 2008 in Guatemala to that in Hungary?
Your answer should be compact. 0.11. What is the ratio of the Payments (BoP, current US$) of 2005 in Hong Kong to that in Hungary?
Your response must be concise. 4.42. What is the ratio of the Payments (BoP, current US$) in 2006 in Hong Kong to that in Hungary?
Your answer should be compact. 4.17. What is the ratio of the Payments (BoP, current US$) of 2007 in Hong Kong to that in Hungary?
Ensure brevity in your answer.  3.72. What is the ratio of the Payments (BoP, current US$) in 2008 in Hong Kong to that in Hungary?
Offer a very short reply. 3.32. What is the difference between the highest and the second highest Payments (BoP, current US$) in 2005?
Your answer should be very brief. 7.52e+11. What is the difference between the highest and the second highest Payments (BoP, current US$) of 2006?
Offer a terse response. 8.73e+11. What is the difference between the highest and the second highest Payments (BoP, current US$) in 2007?
Your answer should be compact. 1.06e+12. What is the difference between the highest and the second highest Payments (BoP, current US$) in 2008?
Make the answer very short. 1.16e+12. What is the difference between the highest and the lowest Payments (BoP, current US$) of 2005?
Offer a very short reply. 1.11e+12. What is the difference between the highest and the lowest Payments (BoP, current US$) in 2006?
Keep it short and to the point. 1.29e+12. What is the difference between the highest and the lowest Payments (BoP, current US$) in 2007?
Offer a very short reply. 1.53e+12. What is the difference between the highest and the lowest Payments (BoP, current US$) of 2008?
Ensure brevity in your answer.  1.66e+12. 